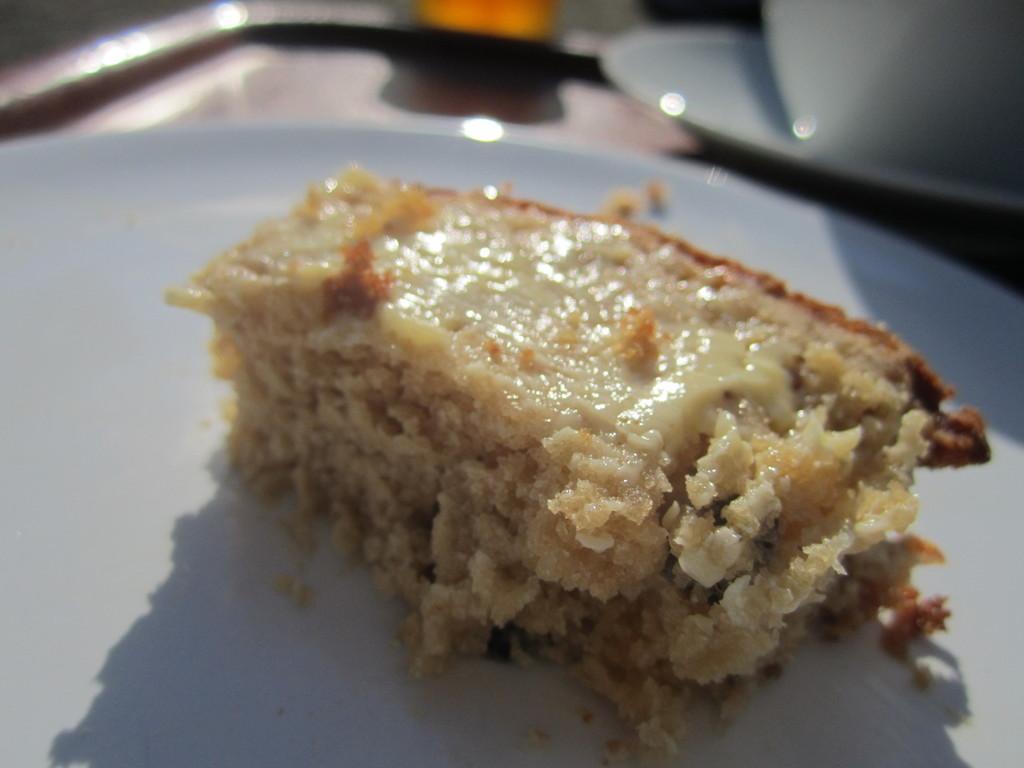In one or two sentences, can you explain what this image depicts? In this image we can see a dessert on the serving plate. 